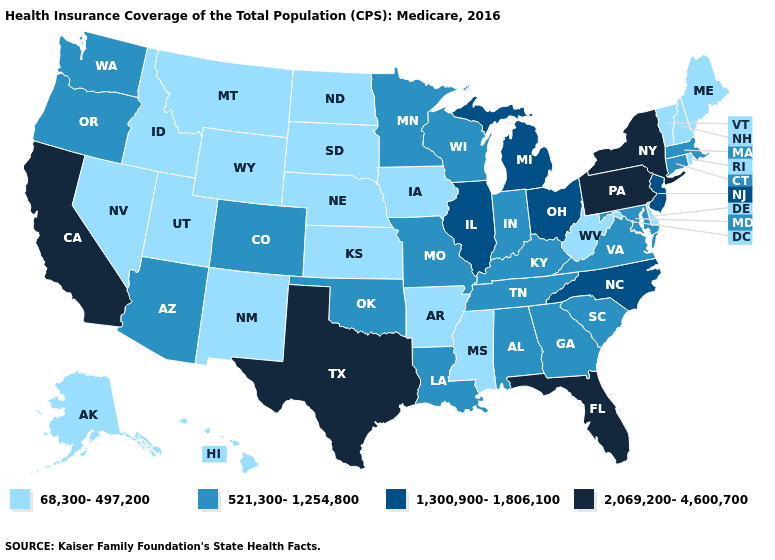Does New York have the lowest value in the Northeast?
Concise answer only. No. Does the first symbol in the legend represent the smallest category?
Keep it brief. Yes. Does Pennsylvania have the highest value in the USA?
Be succinct. Yes. Which states have the highest value in the USA?
Quick response, please. California, Florida, New York, Pennsylvania, Texas. Which states have the highest value in the USA?
Short answer required. California, Florida, New York, Pennsylvania, Texas. Does Kentucky have the highest value in the South?
Give a very brief answer. No. Name the states that have a value in the range 68,300-497,200?
Quick response, please. Alaska, Arkansas, Delaware, Hawaii, Idaho, Iowa, Kansas, Maine, Mississippi, Montana, Nebraska, Nevada, New Hampshire, New Mexico, North Dakota, Rhode Island, South Dakota, Utah, Vermont, West Virginia, Wyoming. What is the value of Oklahoma?
Give a very brief answer. 521,300-1,254,800. Among the states that border Vermont , which have the lowest value?
Concise answer only. New Hampshire. What is the value of Maine?
Give a very brief answer. 68,300-497,200. Name the states that have a value in the range 68,300-497,200?
Write a very short answer. Alaska, Arkansas, Delaware, Hawaii, Idaho, Iowa, Kansas, Maine, Mississippi, Montana, Nebraska, Nevada, New Hampshire, New Mexico, North Dakota, Rhode Island, South Dakota, Utah, Vermont, West Virginia, Wyoming. Does South Carolina have the same value as Georgia?
Write a very short answer. Yes. Name the states that have a value in the range 1,300,900-1,806,100?
Give a very brief answer. Illinois, Michigan, New Jersey, North Carolina, Ohio. Does California have the lowest value in the West?
Write a very short answer. No. How many symbols are there in the legend?
Keep it brief. 4. 